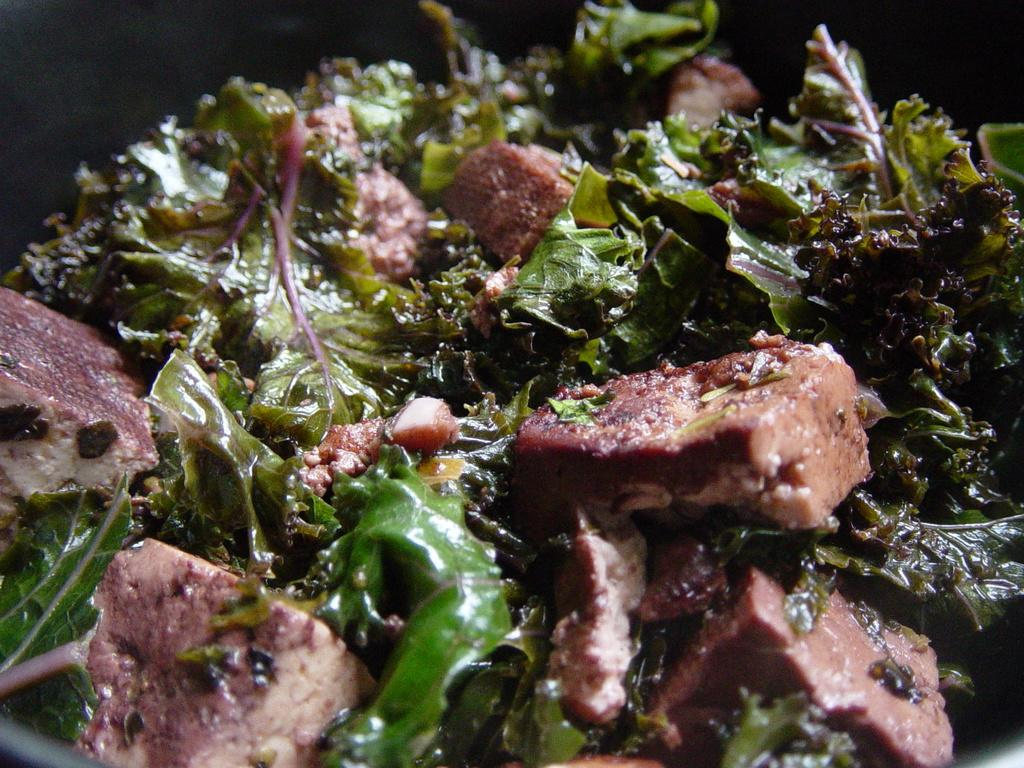What type of dish is featured in the image? There is a non-veg dish in the image. What are the main ingredients of the dish? The dish contains meat and green leafy vegetables. What color is the tooth in the image? There is no tooth present in the image. What type of power source is used to cook the dish in the image? The provided facts do not mention any power source used to cook the dish, so we cannot determine that information from the image. 